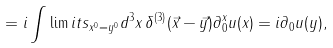Convert formula to latex. <formula><loc_0><loc_0><loc_500><loc_500>= i \int \lim i t s _ { x ^ { 0 } = y ^ { 0 } } d ^ { 3 } x \, \delta ^ { ( 3 ) } ( \vec { x } - \vec { y } ) \partial _ { 0 } ^ { x } u ( x ) = i \partial _ { 0 } u ( y ) ,</formula> 